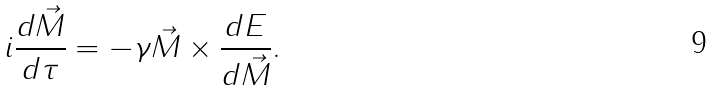Convert formula to latex. <formula><loc_0><loc_0><loc_500><loc_500>i \frac { d \vec { M } } { d \tau } = - \gamma \vec { M } \times \frac { d E } { d \vec { M } } .</formula> 